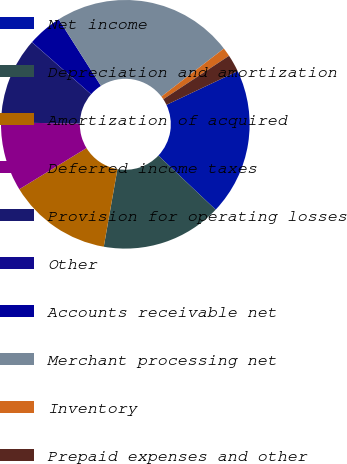Convert chart to OTSL. <chart><loc_0><loc_0><loc_500><loc_500><pie_chart><fcel>Net income<fcel>Depreciation and amortization<fcel>Amortization of acquired<fcel>Deferred income taxes<fcel>Provision for operating losses<fcel>Other<fcel>Accounts receivable net<fcel>Merchant processing net<fcel>Inventory<fcel>Prepaid expenses and other<nl><fcel>19.08%<fcel>15.72%<fcel>13.48%<fcel>8.99%<fcel>11.23%<fcel>0.02%<fcel>4.51%<fcel>23.57%<fcel>1.14%<fcel>2.26%<nl></chart> 